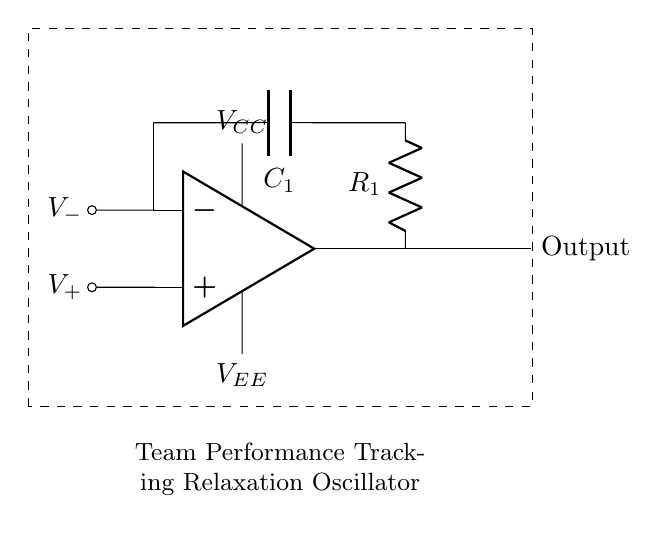What is the type of amplifier used in this circuit? The circuit uses an operational amplifier (op amp), which is indicated by the op amp symbol in the diagram.
Answer: op amp What component provides the timing element in the circuit? The timing element is provided by the combination of the resistor R1 and capacitor C1, as they control the charge and discharge cycles that determine the timing pulses.
Answer: R1 and C1 What is the purpose of the dashed rectangle in the circuit diagram? The dashed rectangle indicates the boundary of the circuit, signifying all the components within it are part of the same sub-circuit, specifically for team performance tracking in this case.
Answer: Circuit boundary How are the power supply voltages labeled in this circuit? The power supply voltages are labeled as VCC and VEE, where VCC is the positive voltage supply and VEE is the negative voltage supply for the op amp.
Answer: VCC and VEE What is the output type of the circuit? The output is represented as an 'Output' label from the op amp, indicating this circuit generates a square wave pulse based on the feedback loop created by R1 and C1.
Answer: Output Which component connects to the inverting input of the op amp? The component that connects to the inverting input of the op amp is the capacitor C1, which is responsible for establishing the timing of the oscillation.
Answer: C1 What function does the resistor R1 serve in the circuit? The resistor R1 determines the charge and discharge rate of the capacitor C1, affecting the frequency of the oscillation or timing pulse output.
Answer: Charge rate 